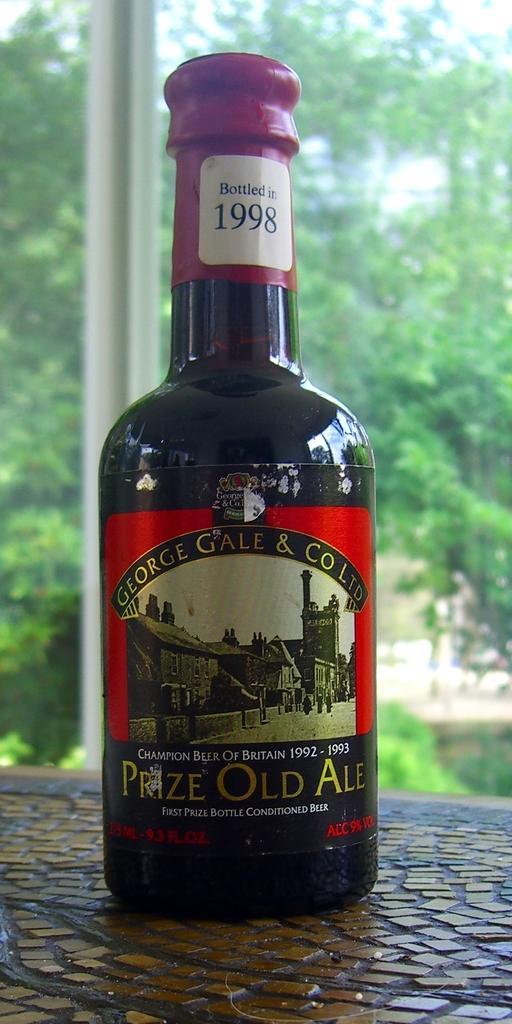In one or two sentences, can you explain what this image depicts? This is a zoomed in picture. In the foreground there is a bottle placed on an object. In the background we can see the sky, trees, plants and a metal rod and we can see the text and the pictures of some buildings on the bottle. 